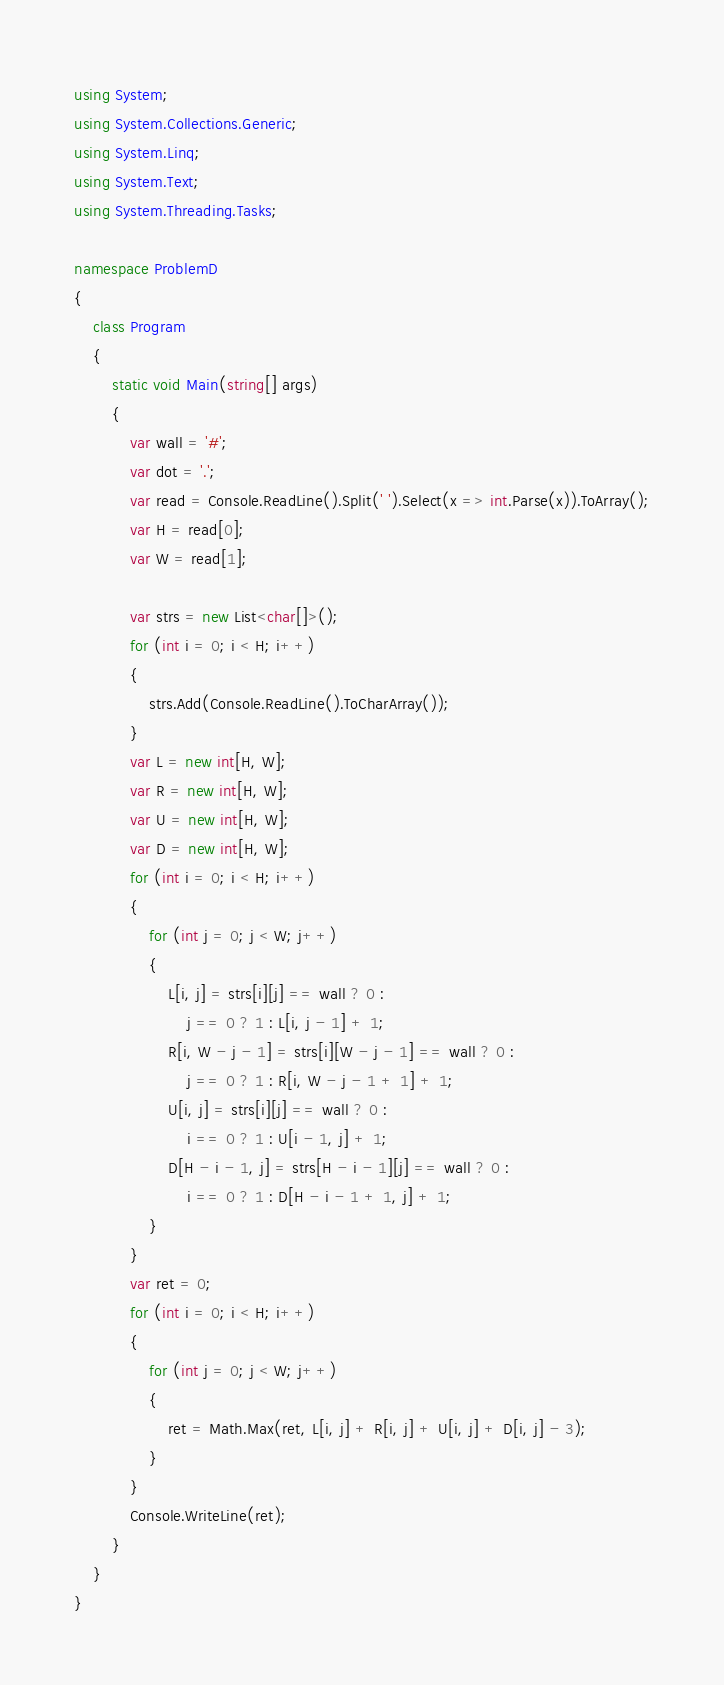Convert code to text. <code><loc_0><loc_0><loc_500><loc_500><_C#_>using System;
using System.Collections.Generic;
using System.Linq;
using System.Text;
using System.Threading.Tasks;

namespace ProblemD
{
    class Program
    {
        static void Main(string[] args)
        {
            var wall = '#';
            var dot = '.';
            var read = Console.ReadLine().Split(' ').Select(x => int.Parse(x)).ToArray();
            var H = read[0];
            var W = read[1];

            var strs = new List<char[]>();
            for (int i = 0; i < H; i++)
            {
                strs.Add(Console.ReadLine().ToCharArray());
            }
            var L = new int[H, W];
            var R = new int[H, W];
            var U = new int[H, W];
            var D = new int[H, W];
            for (int i = 0; i < H; i++)
            {
                for (int j = 0; j < W; j++)
                {
                    L[i, j] = strs[i][j] == wall ? 0 :
                        j == 0 ? 1 : L[i, j - 1] + 1;
                    R[i, W - j - 1] = strs[i][W - j - 1] == wall ? 0 :
                        j == 0 ? 1 : R[i, W - j - 1 + 1] + 1;
                    U[i, j] = strs[i][j] == wall ? 0 :
                        i == 0 ? 1 : U[i - 1, j] + 1;
                    D[H - i - 1, j] = strs[H - i - 1][j] == wall ? 0 :
                        i == 0 ? 1 : D[H - i - 1 + 1, j] + 1;
                }
            }
            var ret = 0;
            for (int i = 0; i < H; i++)
            {
                for (int j = 0; j < W; j++)
                {
                    ret = Math.Max(ret, L[i, j] + R[i, j] + U[i, j] + D[i, j] - 3);
                }
            }
            Console.WriteLine(ret);
        }
    }
}
</code> 